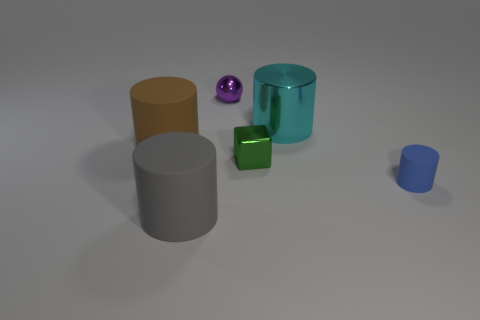Add 2 gray metal blocks. How many objects exist? 8 Subtract all cylinders. How many objects are left? 2 Subtract all yellow shiny balls. Subtract all large matte things. How many objects are left? 4 Add 5 big metallic cylinders. How many big metallic cylinders are left? 6 Add 3 big cyan metallic things. How many big cyan metallic things exist? 4 Subtract 0 gray balls. How many objects are left? 6 